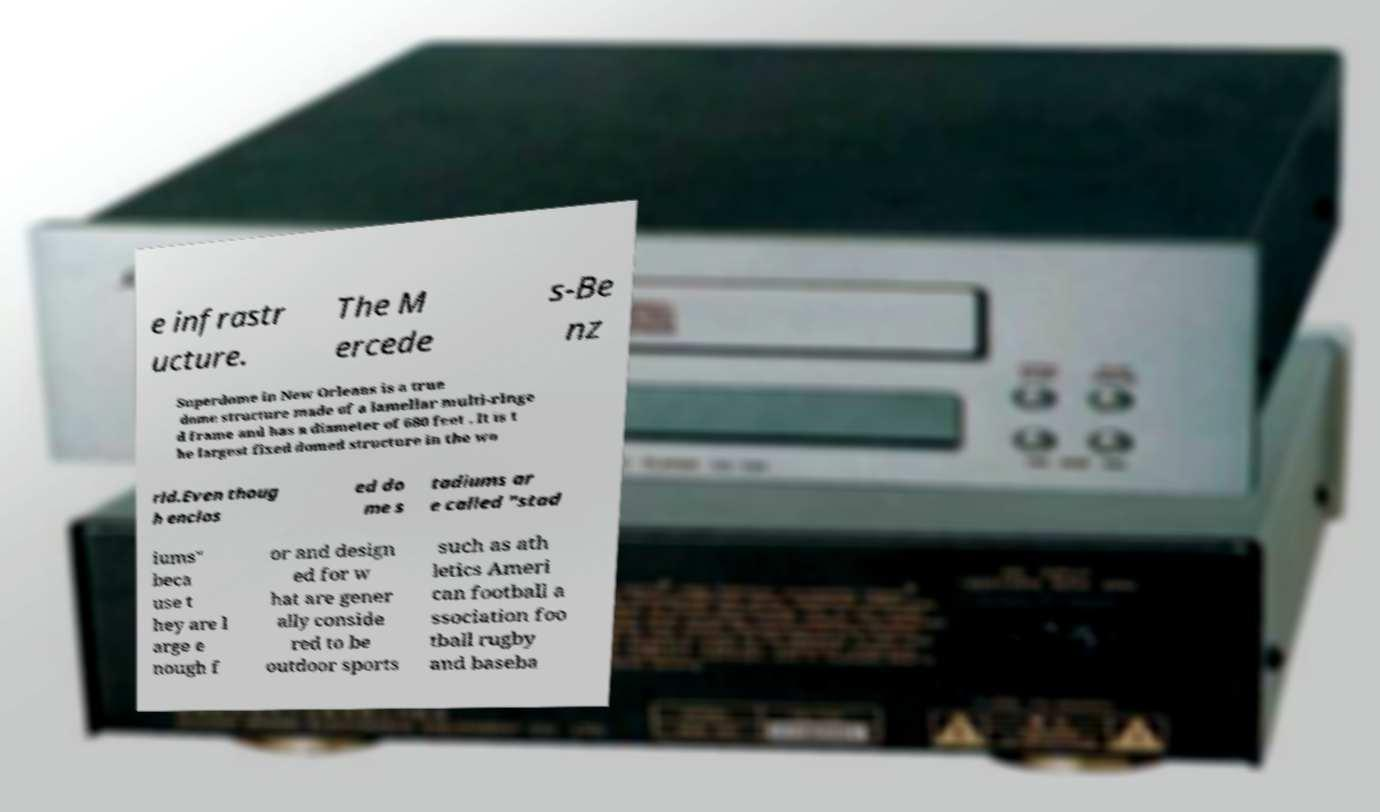Can you read and provide the text displayed in the image?This photo seems to have some interesting text. Can you extract and type it out for me? e infrastr ucture. The M ercede s-Be nz Superdome in New Orleans is a true dome structure made of a lamellar multi-ringe d frame and has a diameter of 680 feet . It is t he largest fixed domed structure in the wo rld.Even thoug h enclos ed do me s tadiums ar e called "stad iums" beca use t hey are l arge e nough f or and design ed for w hat are gener ally conside red to be outdoor sports such as ath letics Ameri can football a ssociation foo tball rugby and baseba 